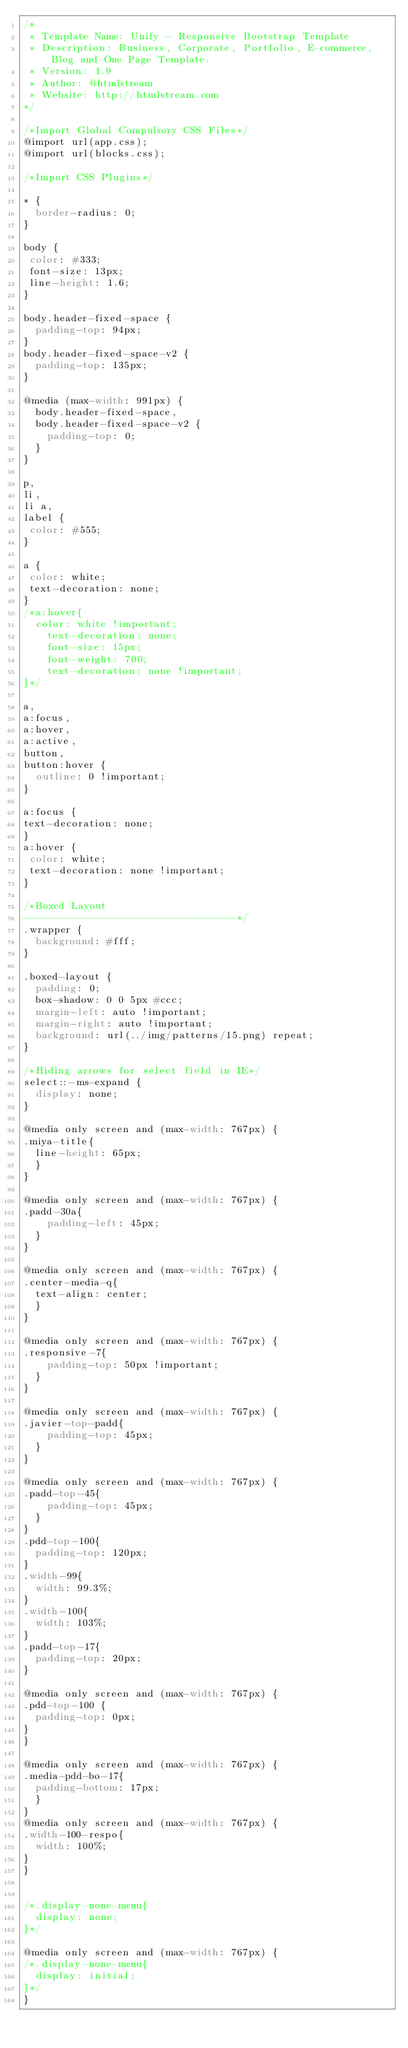Convert code to text. <code><loc_0><loc_0><loc_500><loc_500><_CSS_>/*
 * Template Name: Unify - Responsive Bootstrap Template
 * Description: Business, Corporate, Portfolio, E-commerce, Blog and One Page Template.
 * Version: 1.9
 * Author: @htmlstream
 * Website: http://htmlstream.com
*/

/*Import Global Compulsory CSS Files*/
@import url(app.css);
@import url(blocks.css);

/*Import CSS Plugins*/

* {
	border-radius: 0;
}

body {
 color: #333;
 font-size: 13px;
 line-height: 1.6;
}

body.header-fixed-space {
  padding-top: 94px;
}
body.header-fixed-space-v2 {
	padding-top: 135px;
}

@media (max-width: 991px) {
	body.header-fixed-space,
	body.header-fixed-space-v2 {
		padding-top: 0;
	}
}

p,
li,
li a,
label {
 color: #555;
}

a {
 color: white;
 text-decoration: none;
}
/*a:hover{
	color: white !important;
    text-decoration: none;
    font-size: 15px;
    font-weight: 700;
    text-decoration: none !important;
}*/

a,
a:focus,
a:hover,
a:active,
button,
button:hover {
	outline: 0 !important;
}

a:focus {
text-decoration: none;
}
a:hover {
 color: white;
 text-decoration: none !important;
}

/*Boxed Layout
------------------------------------*/
.wrapper {
	background: #fff;
}

.boxed-layout {
  padding: 0;
  box-shadow: 0 0 5px #ccc;
  margin-left: auto !important;
  margin-right: auto !important;
  background: url(../img/patterns/15.png) repeat;
}

/*Hiding arrows for select field in IE*/
select::-ms-expand {
  display: none;
}

@media only screen and (max-width: 767px) {
.miya-title{
  line-height: 65px;
  }
}

@media only screen and (max-width: 767px) {
.padd-30a{
    padding-left: 45px;
  }
}

@media only screen and (max-width: 767px) {
.center-media-q{
  text-align: center;
  }
}

@media only screen and (max-width: 767px) {
.responsive-7{
    padding-top: 50px !important;
  }
}

@media only screen and (max-width: 767px) {
.javier-top-padd{
    padding-top: 45px;
  }
}

@media only screen and (max-width: 767px) {
.padd-top-45{
    padding-top: 45px;
  }
}
.pdd-top-100{
  padding-top: 120px;
}
.width-99{
  width: 99.3%;
}
.width-100{
  width: 103%;
}
.padd-top-17{
  padding-top: 20px;
}

@media only screen and (max-width: 767px) {
.pdd-top-100 {
  padding-top: 0px;
}
}

@media only screen and (max-width: 767px) {
.media-pdd-bo-17{
  padding-bottom: 17px;
  }
}
@media only screen and (max-width: 767px) {
.width-100-respo{
  width: 100%;
}
}


/*.display-none-menu{
  display: none;
}*/

@media only screen and (max-width: 767px) {
/*.display-none-menu{
  display: initial;
}*/
}</code> 